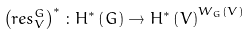<formula> <loc_0><loc_0><loc_500><loc_500>\left ( r e s _ { V } ^ { G } \right ) ^ { \ast } \colon H ^ { \ast } \left ( G \right ) \rightarrow H ^ { \ast } \left ( V \right ) ^ { W _ { G } \left ( V \right ) }</formula> 